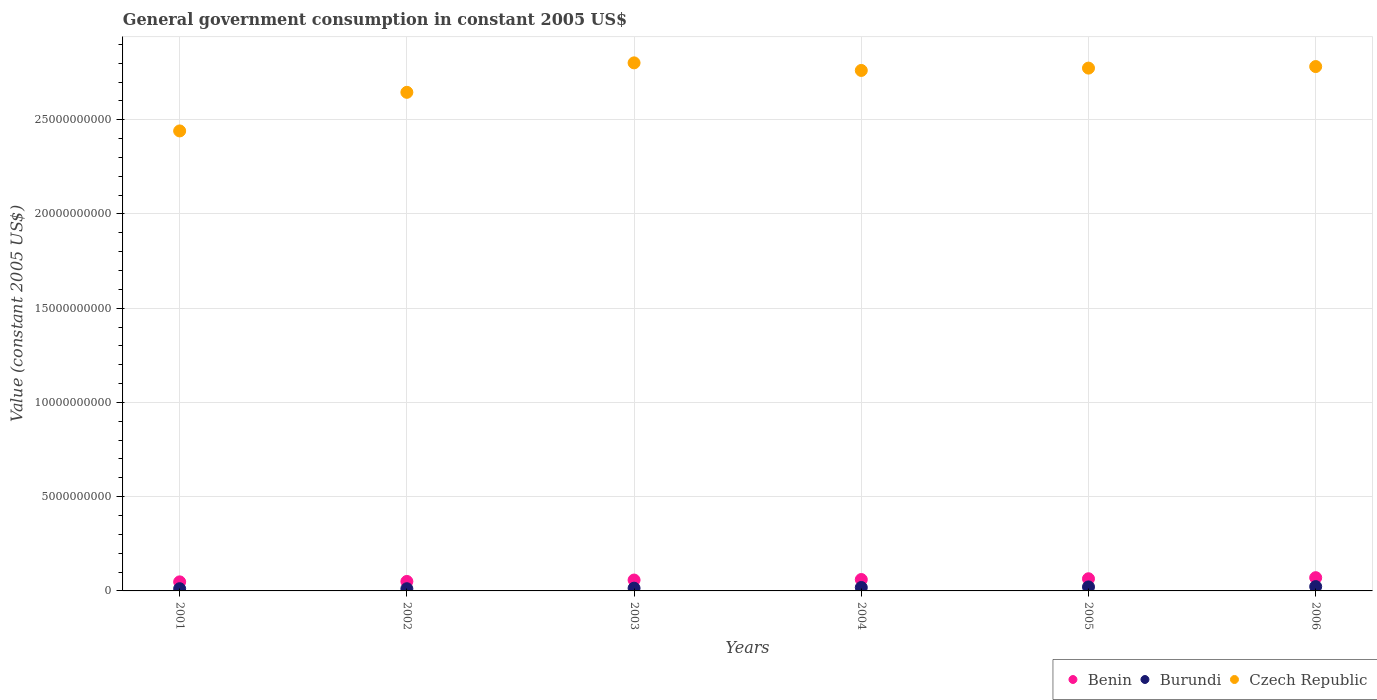How many different coloured dotlines are there?
Your answer should be compact. 3. What is the government conusmption in Czech Republic in 2002?
Offer a terse response. 2.65e+1. Across all years, what is the maximum government conusmption in Benin?
Provide a succinct answer. 7.03e+08. Across all years, what is the minimum government conusmption in Burundi?
Keep it short and to the point. 1.16e+08. In which year was the government conusmption in Benin maximum?
Your answer should be compact. 2006. In which year was the government conusmption in Czech Republic minimum?
Keep it short and to the point. 2001. What is the total government conusmption in Czech Republic in the graph?
Give a very brief answer. 1.62e+11. What is the difference between the government conusmption in Czech Republic in 2004 and that in 2006?
Your answer should be compact. -2.06e+08. What is the difference between the government conusmption in Burundi in 2003 and the government conusmption in Benin in 2001?
Your response must be concise. -3.36e+08. What is the average government conusmption in Benin per year?
Your response must be concise. 5.86e+08. In the year 2005, what is the difference between the government conusmption in Czech Republic and government conusmption in Burundi?
Keep it short and to the point. 2.75e+1. In how many years, is the government conusmption in Czech Republic greater than 27000000000 US$?
Make the answer very short. 4. What is the ratio of the government conusmption in Benin in 2001 to that in 2006?
Offer a terse response. 0.68. Is the difference between the government conusmption in Czech Republic in 2005 and 2006 greater than the difference between the government conusmption in Burundi in 2005 and 2006?
Keep it short and to the point. No. What is the difference between the highest and the second highest government conusmption in Burundi?
Offer a very short reply. 1.79e+07. What is the difference between the highest and the lowest government conusmption in Czech Republic?
Keep it short and to the point. 3.61e+09. In how many years, is the government conusmption in Benin greater than the average government conusmption in Benin taken over all years?
Provide a short and direct response. 3. Is the sum of the government conusmption in Benin in 2004 and 2005 greater than the maximum government conusmption in Burundi across all years?
Your response must be concise. Yes. Is it the case that in every year, the sum of the government conusmption in Burundi and government conusmption in Benin  is greater than the government conusmption in Czech Republic?
Offer a terse response. No. Does the government conusmption in Benin monotonically increase over the years?
Your answer should be compact. Yes. Is the government conusmption in Burundi strictly greater than the government conusmption in Czech Republic over the years?
Offer a very short reply. No. How many dotlines are there?
Your answer should be very brief. 3. How many years are there in the graph?
Offer a terse response. 6. What is the difference between two consecutive major ticks on the Y-axis?
Your answer should be very brief. 5.00e+09. Are the values on the major ticks of Y-axis written in scientific E-notation?
Make the answer very short. No. Does the graph contain grids?
Keep it short and to the point. Yes. Where does the legend appear in the graph?
Make the answer very short. Bottom right. What is the title of the graph?
Offer a terse response. General government consumption in constant 2005 US$. What is the label or title of the X-axis?
Your response must be concise. Years. What is the label or title of the Y-axis?
Provide a succinct answer. Value (constant 2005 US$). What is the Value (constant 2005 US$) of Benin in 2001?
Keep it short and to the point. 4.81e+08. What is the Value (constant 2005 US$) in Burundi in 2001?
Offer a very short reply. 1.17e+08. What is the Value (constant 2005 US$) of Czech Republic in 2001?
Give a very brief answer. 2.44e+1. What is the Value (constant 2005 US$) of Benin in 2002?
Your answer should be very brief. 5.03e+08. What is the Value (constant 2005 US$) of Burundi in 2002?
Offer a terse response. 1.16e+08. What is the Value (constant 2005 US$) in Czech Republic in 2002?
Ensure brevity in your answer.  2.65e+1. What is the Value (constant 2005 US$) in Benin in 2003?
Provide a short and direct response. 5.77e+08. What is the Value (constant 2005 US$) of Burundi in 2003?
Your answer should be very brief. 1.45e+08. What is the Value (constant 2005 US$) of Czech Republic in 2003?
Your answer should be very brief. 2.80e+1. What is the Value (constant 2005 US$) of Benin in 2004?
Provide a succinct answer. 6.05e+08. What is the Value (constant 2005 US$) in Burundi in 2004?
Give a very brief answer. 1.82e+08. What is the Value (constant 2005 US$) in Czech Republic in 2004?
Your response must be concise. 2.76e+1. What is the Value (constant 2005 US$) of Benin in 2005?
Your answer should be very brief. 6.46e+08. What is the Value (constant 2005 US$) in Burundi in 2005?
Your response must be concise. 2.12e+08. What is the Value (constant 2005 US$) in Czech Republic in 2005?
Ensure brevity in your answer.  2.77e+1. What is the Value (constant 2005 US$) of Benin in 2006?
Keep it short and to the point. 7.03e+08. What is the Value (constant 2005 US$) in Burundi in 2006?
Your answer should be very brief. 2.30e+08. What is the Value (constant 2005 US$) in Czech Republic in 2006?
Your answer should be compact. 2.78e+1. Across all years, what is the maximum Value (constant 2005 US$) of Benin?
Offer a terse response. 7.03e+08. Across all years, what is the maximum Value (constant 2005 US$) of Burundi?
Make the answer very short. 2.30e+08. Across all years, what is the maximum Value (constant 2005 US$) of Czech Republic?
Offer a very short reply. 2.80e+1. Across all years, what is the minimum Value (constant 2005 US$) of Benin?
Your answer should be very brief. 4.81e+08. Across all years, what is the minimum Value (constant 2005 US$) of Burundi?
Give a very brief answer. 1.16e+08. Across all years, what is the minimum Value (constant 2005 US$) in Czech Republic?
Offer a very short reply. 2.44e+1. What is the total Value (constant 2005 US$) of Benin in the graph?
Offer a very short reply. 3.51e+09. What is the total Value (constant 2005 US$) in Burundi in the graph?
Your answer should be compact. 1.00e+09. What is the total Value (constant 2005 US$) in Czech Republic in the graph?
Keep it short and to the point. 1.62e+11. What is the difference between the Value (constant 2005 US$) of Benin in 2001 and that in 2002?
Your answer should be very brief. -2.21e+07. What is the difference between the Value (constant 2005 US$) of Burundi in 2001 and that in 2002?
Your answer should be very brief. 7.17e+05. What is the difference between the Value (constant 2005 US$) in Czech Republic in 2001 and that in 2002?
Make the answer very short. -2.05e+09. What is the difference between the Value (constant 2005 US$) in Benin in 2001 and that in 2003?
Ensure brevity in your answer.  -9.65e+07. What is the difference between the Value (constant 2005 US$) of Burundi in 2001 and that in 2003?
Make the answer very short. -2.80e+07. What is the difference between the Value (constant 2005 US$) of Czech Republic in 2001 and that in 2003?
Offer a very short reply. -3.61e+09. What is the difference between the Value (constant 2005 US$) of Benin in 2001 and that in 2004?
Make the answer very short. -1.24e+08. What is the difference between the Value (constant 2005 US$) in Burundi in 2001 and that in 2004?
Provide a succinct answer. -6.49e+07. What is the difference between the Value (constant 2005 US$) in Czech Republic in 2001 and that in 2004?
Make the answer very short. -3.21e+09. What is the difference between the Value (constant 2005 US$) in Benin in 2001 and that in 2005?
Your answer should be compact. -1.65e+08. What is the difference between the Value (constant 2005 US$) in Burundi in 2001 and that in 2005?
Offer a terse response. -9.50e+07. What is the difference between the Value (constant 2005 US$) in Czech Republic in 2001 and that in 2005?
Offer a very short reply. -3.33e+09. What is the difference between the Value (constant 2005 US$) in Benin in 2001 and that in 2006?
Your answer should be compact. -2.22e+08. What is the difference between the Value (constant 2005 US$) of Burundi in 2001 and that in 2006?
Ensure brevity in your answer.  -1.13e+08. What is the difference between the Value (constant 2005 US$) of Czech Republic in 2001 and that in 2006?
Provide a succinct answer. -3.42e+09. What is the difference between the Value (constant 2005 US$) in Benin in 2002 and that in 2003?
Make the answer very short. -7.44e+07. What is the difference between the Value (constant 2005 US$) of Burundi in 2002 and that in 2003?
Ensure brevity in your answer.  -2.87e+07. What is the difference between the Value (constant 2005 US$) of Czech Republic in 2002 and that in 2003?
Your answer should be compact. -1.56e+09. What is the difference between the Value (constant 2005 US$) in Benin in 2002 and that in 2004?
Offer a terse response. -1.02e+08. What is the difference between the Value (constant 2005 US$) in Burundi in 2002 and that in 2004?
Your answer should be very brief. -6.56e+07. What is the difference between the Value (constant 2005 US$) in Czech Republic in 2002 and that in 2004?
Give a very brief answer. -1.16e+09. What is the difference between the Value (constant 2005 US$) in Benin in 2002 and that in 2005?
Provide a short and direct response. -1.43e+08. What is the difference between the Value (constant 2005 US$) in Burundi in 2002 and that in 2005?
Your answer should be very brief. -9.57e+07. What is the difference between the Value (constant 2005 US$) in Czech Republic in 2002 and that in 2005?
Offer a very short reply. -1.28e+09. What is the difference between the Value (constant 2005 US$) in Benin in 2002 and that in 2006?
Provide a succinct answer. -2.00e+08. What is the difference between the Value (constant 2005 US$) in Burundi in 2002 and that in 2006?
Provide a succinct answer. -1.14e+08. What is the difference between the Value (constant 2005 US$) of Czech Republic in 2002 and that in 2006?
Keep it short and to the point. -1.37e+09. What is the difference between the Value (constant 2005 US$) of Benin in 2003 and that in 2004?
Provide a succinct answer. -2.78e+07. What is the difference between the Value (constant 2005 US$) in Burundi in 2003 and that in 2004?
Give a very brief answer. -3.69e+07. What is the difference between the Value (constant 2005 US$) in Czech Republic in 2003 and that in 2004?
Offer a terse response. 4.02e+08. What is the difference between the Value (constant 2005 US$) in Benin in 2003 and that in 2005?
Offer a terse response. -6.83e+07. What is the difference between the Value (constant 2005 US$) in Burundi in 2003 and that in 2005?
Give a very brief answer. -6.70e+07. What is the difference between the Value (constant 2005 US$) of Czech Republic in 2003 and that in 2005?
Give a very brief answer. 2.78e+08. What is the difference between the Value (constant 2005 US$) of Benin in 2003 and that in 2006?
Keep it short and to the point. -1.26e+08. What is the difference between the Value (constant 2005 US$) in Burundi in 2003 and that in 2006?
Offer a very short reply. -8.49e+07. What is the difference between the Value (constant 2005 US$) of Czech Republic in 2003 and that in 2006?
Your response must be concise. 1.96e+08. What is the difference between the Value (constant 2005 US$) in Benin in 2004 and that in 2005?
Provide a short and direct response. -4.05e+07. What is the difference between the Value (constant 2005 US$) in Burundi in 2004 and that in 2005?
Keep it short and to the point. -3.01e+07. What is the difference between the Value (constant 2005 US$) in Czech Republic in 2004 and that in 2005?
Offer a very short reply. -1.24e+08. What is the difference between the Value (constant 2005 US$) in Benin in 2004 and that in 2006?
Make the answer very short. -9.78e+07. What is the difference between the Value (constant 2005 US$) in Burundi in 2004 and that in 2006?
Your response must be concise. -4.79e+07. What is the difference between the Value (constant 2005 US$) of Czech Republic in 2004 and that in 2006?
Keep it short and to the point. -2.06e+08. What is the difference between the Value (constant 2005 US$) in Benin in 2005 and that in 2006?
Ensure brevity in your answer.  -5.72e+07. What is the difference between the Value (constant 2005 US$) in Burundi in 2005 and that in 2006?
Offer a terse response. -1.79e+07. What is the difference between the Value (constant 2005 US$) in Czech Republic in 2005 and that in 2006?
Your answer should be compact. -8.24e+07. What is the difference between the Value (constant 2005 US$) in Benin in 2001 and the Value (constant 2005 US$) in Burundi in 2002?
Provide a short and direct response. 3.64e+08. What is the difference between the Value (constant 2005 US$) in Benin in 2001 and the Value (constant 2005 US$) in Czech Republic in 2002?
Provide a short and direct response. -2.60e+1. What is the difference between the Value (constant 2005 US$) in Burundi in 2001 and the Value (constant 2005 US$) in Czech Republic in 2002?
Give a very brief answer. -2.63e+1. What is the difference between the Value (constant 2005 US$) in Benin in 2001 and the Value (constant 2005 US$) in Burundi in 2003?
Offer a terse response. 3.36e+08. What is the difference between the Value (constant 2005 US$) in Benin in 2001 and the Value (constant 2005 US$) in Czech Republic in 2003?
Offer a very short reply. -2.75e+1. What is the difference between the Value (constant 2005 US$) of Burundi in 2001 and the Value (constant 2005 US$) of Czech Republic in 2003?
Keep it short and to the point. -2.79e+1. What is the difference between the Value (constant 2005 US$) in Benin in 2001 and the Value (constant 2005 US$) in Burundi in 2004?
Keep it short and to the point. 2.99e+08. What is the difference between the Value (constant 2005 US$) of Benin in 2001 and the Value (constant 2005 US$) of Czech Republic in 2004?
Give a very brief answer. -2.71e+1. What is the difference between the Value (constant 2005 US$) in Burundi in 2001 and the Value (constant 2005 US$) in Czech Republic in 2004?
Keep it short and to the point. -2.75e+1. What is the difference between the Value (constant 2005 US$) in Benin in 2001 and the Value (constant 2005 US$) in Burundi in 2005?
Offer a terse response. 2.69e+08. What is the difference between the Value (constant 2005 US$) of Benin in 2001 and the Value (constant 2005 US$) of Czech Republic in 2005?
Make the answer very short. -2.73e+1. What is the difference between the Value (constant 2005 US$) in Burundi in 2001 and the Value (constant 2005 US$) in Czech Republic in 2005?
Offer a terse response. -2.76e+1. What is the difference between the Value (constant 2005 US$) in Benin in 2001 and the Value (constant 2005 US$) in Burundi in 2006?
Provide a short and direct response. 2.51e+08. What is the difference between the Value (constant 2005 US$) of Benin in 2001 and the Value (constant 2005 US$) of Czech Republic in 2006?
Give a very brief answer. -2.73e+1. What is the difference between the Value (constant 2005 US$) of Burundi in 2001 and the Value (constant 2005 US$) of Czech Republic in 2006?
Your answer should be very brief. -2.77e+1. What is the difference between the Value (constant 2005 US$) in Benin in 2002 and the Value (constant 2005 US$) in Burundi in 2003?
Make the answer very short. 3.58e+08. What is the difference between the Value (constant 2005 US$) in Benin in 2002 and the Value (constant 2005 US$) in Czech Republic in 2003?
Your response must be concise. -2.75e+1. What is the difference between the Value (constant 2005 US$) of Burundi in 2002 and the Value (constant 2005 US$) of Czech Republic in 2003?
Give a very brief answer. -2.79e+1. What is the difference between the Value (constant 2005 US$) in Benin in 2002 and the Value (constant 2005 US$) in Burundi in 2004?
Your response must be concise. 3.21e+08. What is the difference between the Value (constant 2005 US$) of Benin in 2002 and the Value (constant 2005 US$) of Czech Republic in 2004?
Give a very brief answer. -2.71e+1. What is the difference between the Value (constant 2005 US$) in Burundi in 2002 and the Value (constant 2005 US$) in Czech Republic in 2004?
Your answer should be compact. -2.75e+1. What is the difference between the Value (constant 2005 US$) of Benin in 2002 and the Value (constant 2005 US$) of Burundi in 2005?
Your answer should be compact. 2.91e+08. What is the difference between the Value (constant 2005 US$) in Benin in 2002 and the Value (constant 2005 US$) in Czech Republic in 2005?
Ensure brevity in your answer.  -2.72e+1. What is the difference between the Value (constant 2005 US$) of Burundi in 2002 and the Value (constant 2005 US$) of Czech Republic in 2005?
Your response must be concise. -2.76e+1. What is the difference between the Value (constant 2005 US$) of Benin in 2002 and the Value (constant 2005 US$) of Burundi in 2006?
Offer a terse response. 2.73e+08. What is the difference between the Value (constant 2005 US$) of Benin in 2002 and the Value (constant 2005 US$) of Czech Republic in 2006?
Your answer should be compact. -2.73e+1. What is the difference between the Value (constant 2005 US$) in Burundi in 2002 and the Value (constant 2005 US$) in Czech Republic in 2006?
Offer a terse response. -2.77e+1. What is the difference between the Value (constant 2005 US$) in Benin in 2003 and the Value (constant 2005 US$) in Burundi in 2004?
Offer a very short reply. 3.95e+08. What is the difference between the Value (constant 2005 US$) of Benin in 2003 and the Value (constant 2005 US$) of Czech Republic in 2004?
Your answer should be compact. -2.70e+1. What is the difference between the Value (constant 2005 US$) in Burundi in 2003 and the Value (constant 2005 US$) in Czech Republic in 2004?
Your response must be concise. -2.75e+1. What is the difference between the Value (constant 2005 US$) in Benin in 2003 and the Value (constant 2005 US$) in Burundi in 2005?
Your answer should be very brief. 3.65e+08. What is the difference between the Value (constant 2005 US$) of Benin in 2003 and the Value (constant 2005 US$) of Czech Republic in 2005?
Your answer should be very brief. -2.72e+1. What is the difference between the Value (constant 2005 US$) in Burundi in 2003 and the Value (constant 2005 US$) in Czech Republic in 2005?
Your answer should be very brief. -2.76e+1. What is the difference between the Value (constant 2005 US$) of Benin in 2003 and the Value (constant 2005 US$) of Burundi in 2006?
Your answer should be compact. 3.47e+08. What is the difference between the Value (constant 2005 US$) of Benin in 2003 and the Value (constant 2005 US$) of Czech Republic in 2006?
Keep it short and to the point. -2.72e+1. What is the difference between the Value (constant 2005 US$) in Burundi in 2003 and the Value (constant 2005 US$) in Czech Republic in 2006?
Give a very brief answer. -2.77e+1. What is the difference between the Value (constant 2005 US$) in Benin in 2004 and the Value (constant 2005 US$) in Burundi in 2005?
Provide a succinct answer. 3.93e+08. What is the difference between the Value (constant 2005 US$) in Benin in 2004 and the Value (constant 2005 US$) in Czech Republic in 2005?
Your answer should be compact. -2.71e+1. What is the difference between the Value (constant 2005 US$) in Burundi in 2004 and the Value (constant 2005 US$) in Czech Republic in 2005?
Ensure brevity in your answer.  -2.76e+1. What is the difference between the Value (constant 2005 US$) in Benin in 2004 and the Value (constant 2005 US$) in Burundi in 2006?
Make the answer very short. 3.75e+08. What is the difference between the Value (constant 2005 US$) in Benin in 2004 and the Value (constant 2005 US$) in Czech Republic in 2006?
Offer a very short reply. -2.72e+1. What is the difference between the Value (constant 2005 US$) of Burundi in 2004 and the Value (constant 2005 US$) of Czech Republic in 2006?
Make the answer very short. -2.76e+1. What is the difference between the Value (constant 2005 US$) in Benin in 2005 and the Value (constant 2005 US$) in Burundi in 2006?
Your response must be concise. 4.15e+08. What is the difference between the Value (constant 2005 US$) in Benin in 2005 and the Value (constant 2005 US$) in Czech Republic in 2006?
Your answer should be compact. -2.72e+1. What is the difference between the Value (constant 2005 US$) in Burundi in 2005 and the Value (constant 2005 US$) in Czech Republic in 2006?
Your answer should be compact. -2.76e+1. What is the average Value (constant 2005 US$) of Benin per year?
Provide a short and direct response. 5.86e+08. What is the average Value (constant 2005 US$) of Burundi per year?
Keep it short and to the point. 1.67e+08. What is the average Value (constant 2005 US$) in Czech Republic per year?
Make the answer very short. 2.70e+1. In the year 2001, what is the difference between the Value (constant 2005 US$) of Benin and Value (constant 2005 US$) of Burundi?
Make the answer very short. 3.64e+08. In the year 2001, what is the difference between the Value (constant 2005 US$) of Benin and Value (constant 2005 US$) of Czech Republic?
Provide a succinct answer. -2.39e+1. In the year 2001, what is the difference between the Value (constant 2005 US$) of Burundi and Value (constant 2005 US$) of Czech Republic?
Provide a succinct answer. -2.43e+1. In the year 2002, what is the difference between the Value (constant 2005 US$) in Benin and Value (constant 2005 US$) in Burundi?
Your answer should be compact. 3.86e+08. In the year 2002, what is the difference between the Value (constant 2005 US$) of Benin and Value (constant 2005 US$) of Czech Republic?
Keep it short and to the point. -2.59e+1. In the year 2002, what is the difference between the Value (constant 2005 US$) of Burundi and Value (constant 2005 US$) of Czech Republic?
Provide a succinct answer. -2.63e+1. In the year 2003, what is the difference between the Value (constant 2005 US$) of Benin and Value (constant 2005 US$) of Burundi?
Your answer should be compact. 4.32e+08. In the year 2003, what is the difference between the Value (constant 2005 US$) in Benin and Value (constant 2005 US$) in Czech Republic?
Your response must be concise. -2.74e+1. In the year 2003, what is the difference between the Value (constant 2005 US$) of Burundi and Value (constant 2005 US$) of Czech Republic?
Give a very brief answer. -2.79e+1. In the year 2004, what is the difference between the Value (constant 2005 US$) in Benin and Value (constant 2005 US$) in Burundi?
Make the answer very short. 4.23e+08. In the year 2004, what is the difference between the Value (constant 2005 US$) of Benin and Value (constant 2005 US$) of Czech Republic?
Your response must be concise. -2.70e+1. In the year 2004, what is the difference between the Value (constant 2005 US$) of Burundi and Value (constant 2005 US$) of Czech Republic?
Offer a very short reply. -2.74e+1. In the year 2005, what is the difference between the Value (constant 2005 US$) in Benin and Value (constant 2005 US$) in Burundi?
Keep it short and to the point. 4.33e+08. In the year 2005, what is the difference between the Value (constant 2005 US$) of Benin and Value (constant 2005 US$) of Czech Republic?
Make the answer very short. -2.71e+1. In the year 2005, what is the difference between the Value (constant 2005 US$) of Burundi and Value (constant 2005 US$) of Czech Republic?
Make the answer very short. -2.75e+1. In the year 2006, what is the difference between the Value (constant 2005 US$) in Benin and Value (constant 2005 US$) in Burundi?
Offer a terse response. 4.73e+08. In the year 2006, what is the difference between the Value (constant 2005 US$) in Benin and Value (constant 2005 US$) in Czech Republic?
Offer a terse response. -2.71e+1. In the year 2006, what is the difference between the Value (constant 2005 US$) in Burundi and Value (constant 2005 US$) in Czech Republic?
Your answer should be compact. -2.76e+1. What is the ratio of the Value (constant 2005 US$) of Benin in 2001 to that in 2002?
Provide a short and direct response. 0.96. What is the ratio of the Value (constant 2005 US$) in Burundi in 2001 to that in 2002?
Give a very brief answer. 1.01. What is the ratio of the Value (constant 2005 US$) of Czech Republic in 2001 to that in 2002?
Ensure brevity in your answer.  0.92. What is the ratio of the Value (constant 2005 US$) in Benin in 2001 to that in 2003?
Make the answer very short. 0.83. What is the ratio of the Value (constant 2005 US$) of Burundi in 2001 to that in 2003?
Your answer should be compact. 0.81. What is the ratio of the Value (constant 2005 US$) in Czech Republic in 2001 to that in 2003?
Your response must be concise. 0.87. What is the ratio of the Value (constant 2005 US$) of Benin in 2001 to that in 2004?
Give a very brief answer. 0.79. What is the ratio of the Value (constant 2005 US$) in Burundi in 2001 to that in 2004?
Offer a very short reply. 0.64. What is the ratio of the Value (constant 2005 US$) of Czech Republic in 2001 to that in 2004?
Ensure brevity in your answer.  0.88. What is the ratio of the Value (constant 2005 US$) of Benin in 2001 to that in 2005?
Provide a short and direct response. 0.74. What is the ratio of the Value (constant 2005 US$) of Burundi in 2001 to that in 2005?
Give a very brief answer. 0.55. What is the ratio of the Value (constant 2005 US$) in Czech Republic in 2001 to that in 2005?
Keep it short and to the point. 0.88. What is the ratio of the Value (constant 2005 US$) in Benin in 2001 to that in 2006?
Your response must be concise. 0.68. What is the ratio of the Value (constant 2005 US$) in Burundi in 2001 to that in 2006?
Your answer should be very brief. 0.51. What is the ratio of the Value (constant 2005 US$) of Czech Republic in 2001 to that in 2006?
Ensure brevity in your answer.  0.88. What is the ratio of the Value (constant 2005 US$) in Benin in 2002 to that in 2003?
Ensure brevity in your answer.  0.87. What is the ratio of the Value (constant 2005 US$) in Burundi in 2002 to that in 2003?
Keep it short and to the point. 0.8. What is the ratio of the Value (constant 2005 US$) in Czech Republic in 2002 to that in 2003?
Provide a short and direct response. 0.94. What is the ratio of the Value (constant 2005 US$) of Benin in 2002 to that in 2004?
Keep it short and to the point. 0.83. What is the ratio of the Value (constant 2005 US$) of Burundi in 2002 to that in 2004?
Keep it short and to the point. 0.64. What is the ratio of the Value (constant 2005 US$) in Czech Republic in 2002 to that in 2004?
Your answer should be compact. 0.96. What is the ratio of the Value (constant 2005 US$) of Benin in 2002 to that in 2005?
Your response must be concise. 0.78. What is the ratio of the Value (constant 2005 US$) of Burundi in 2002 to that in 2005?
Make the answer very short. 0.55. What is the ratio of the Value (constant 2005 US$) of Czech Republic in 2002 to that in 2005?
Provide a succinct answer. 0.95. What is the ratio of the Value (constant 2005 US$) of Benin in 2002 to that in 2006?
Your response must be concise. 0.72. What is the ratio of the Value (constant 2005 US$) of Burundi in 2002 to that in 2006?
Your answer should be very brief. 0.51. What is the ratio of the Value (constant 2005 US$) in Czech Republic in 2002 to that in 2006?
Your response must be concise. 0.95. What is the ratio of the Value (constant 2005 US$) of Benin in 2003 to that in 2004?
Give a very brief answer. 0.95. What is the ratio of the Value (constant 2005 US$) in Burundi in 2003 to that in 2004?
Keep it short and to the point. 0.8. What is the ratio of the Value (constant 2005 US$) in Czech Republic in 2003 to that in 2004?
Ensure brevity in your answer.  1.01. What is the ratio of the Value (constant 2005 US$) of Benin in 2003 to that in 2005?
Your answer should be very brief. 0.89. What is the ratio of the Value (constant 2005 US$) in Burundi in 2003 to that in 2005?
Your answer should be compact. 0.68. What is the ratio of the Value (constant 2005 US$) in Czech Republic in 2003 to that in 2005?
Provide a succinct answer. 1.01. What is the ratio of the Value (constant 2005 US$) in Benin in 2003 to that in 2006?
Ensure brevity in your answer.  0.82. What is the ratio of the Value (constant 2005 US$) of Burundi in 2003 to that in 2006?
Offer a very short reply. 0.63. What is the ratio of the Value (constant 2005 US$) in Benin in 2004 to that in 2005?
Ensure brevity in your answer.  0.94. What is the ratio of the Value (constant 2005 US$) in Burundi in 2004 to that in 2005?
Your response must be concise. 0.86. What is the ratio of the Value (constant 2005 US$) of Czech Republic in 2004 to that in 2005?
Offer a very short reply. 1. What is the ratio of the Value (constant 2005 US$) in Benin in 2004 to that in 2006?
Provide a short and direct response. 0.86. What is the ratio of the Value (constant 2005 US$) of Burundi in 2004 to that in 2006?
Offer a very short reply. 0.79. What is the ratio of the Value (constant 2005 US$) in Czech Republic in 2004 to that in 2006?
Ensure brevity in your answer.  0.99. What is the ratio of the Value (constant 2005 US$) in Benin in 2005 to that in 2006?
Keep it short and to the point. 0.92. What is the ratio of the Value (constant 2005 US$) in Burundi in 2005 to that in 2006?
Ensure brevity in your answer.  0.92. What is the difference between the highest and the second highest Value (constant 2005 US$) in Benin?
Your answer should be compact. 5.72e+07. What is the difference between the highest and the second highest Value (constant 2005 US$) in Burundi?
Provide a succinct answer. 1.79e+07. What is the difference between the highest and the second highest Value (constant 2005 US$) of Czech Republic?
Keep it short and to the point. 1.96e+08. What is the difference between the highest and the lowest Value (constant 2005 US$) in Benin?
Keep it short and to the point. 2.22e+08. What is the difference between the highest and the lowest Value (constant 2005 US$) of Burundi?
Keep it short and to the point. 1.14e+08. What is the difference between the highest and the lowest Value (constant 2005 US$) in Czech Republic?
Provide a short and direct response. 3.61e+09. 